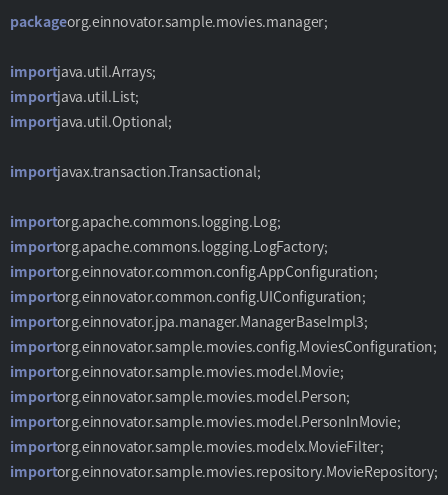Convert code to text. <code><loc_0><loc_0><loc_500><loc_500><_Java_>package org.einnovator.sample.movies.manager;

import java.util.Arrays;
import java.util.List;
import java.util.Optional;

import javax.transaction.Transactional;

import org.apache.commons.logging.Log;
import org.apache.commons.logging.LogFactory;
import org.einnovator.common.config.AppConfiguration;
import org.einnovator.common.config.UIConfiguration;
import org.einnovator.jpa.manager.ManagerBaseImpl3;
import org.einnovator.sample.movies.config.MoviesConfiguration;
import org.einnovator.sample.movies.model.Movie;
import org.einnovator.sample.movies.model.Person;
import org.einnovator.sample.movies.model.PersonInMovie;
import org.einnovator.sample.movies.modelx.MovieFilter;
import org.einnovator.sample.movies.repository.MovieRepository;</code> 